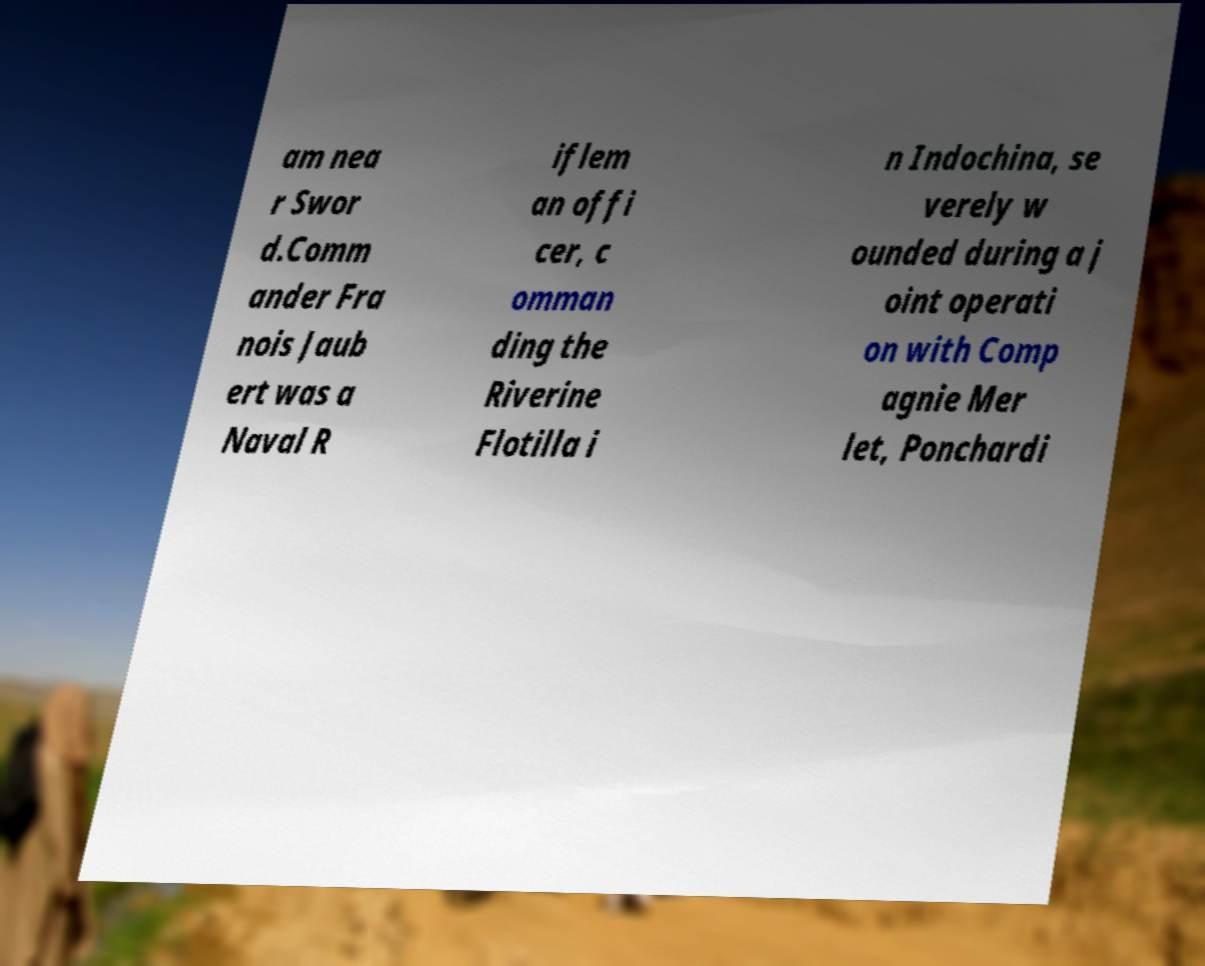Please identify and transcribe the text found in this image. am nea r Swor d.Comm ander Fra nois Jaub ert was a Naval R iflem an offi cer, c omman ding the Riverine Flotilla i n Indochina, se verely w ounded during a j oint operati on with Comp agnie Mer let, Ponchardi 